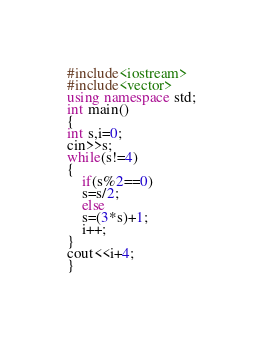Convert code to text. <code><loc_0><loc_0><loc_500><loc_500><_C++_>#include<iostream>
#include<vector>
using namespace std;
int main()
{
int s,i=0;
cin>>s;
while(s!=4)
{
	if(s%2==0)
	s=s/2;
	else
	s=(3*s)+1;
	i++;
}
cout<<i+4;
}</code> 